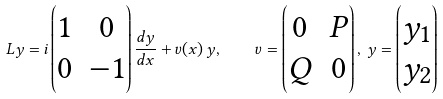Convert formula to latex. <formula><loc_0><loc_0><loc_500><loc_500>L y = i \begin{pmatrix} 1 & 0 \\ 0 & - 1 \end{pmatrix} \frac { d y } { d x } + v ( x ) \, y , \quad v = \begin{pmatrix} 0 & P \\ Q & 0 \end{pmatrix} , \, y = \begin{pmatrix} y _ { 1 } \\ y _ { 2 } \end{pmatrix}</formula> 